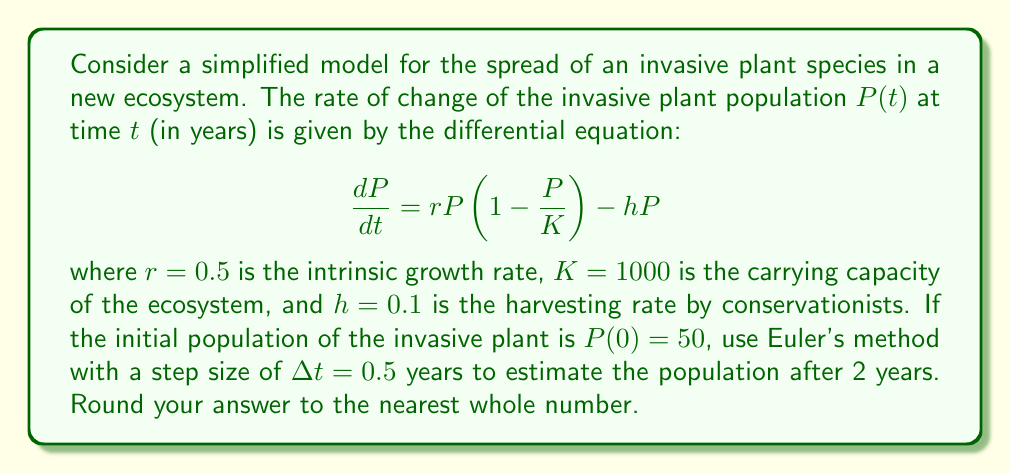Provide a solution to this math problem. To solve this problem using Euler's method, we'll follow these steps:

1) Euler's method is given by the formula:
   $$P_{n+1} = P_n + \Delta t \cdot f(t_n, P_n)$$
   where $f(t, P) = \frac{dP}{dt} = rP(1 - \frac{P}{K}) - hP$

2) Given:
   $r = 0.5$, $K = 1000$, $h = 0.1$, $P(0) = 50$, $\Delta t = 0.5$

3) We need to calculate 4 steps to reach 2 years:
   $t_0 = 0$, $t_1 = 0.5$, $t_2 = 1$, $t_3 = 1.5$, $t_4 = 2$

4) Let's calculate each step:

   Step 1 ($t_0 = 0$ to $t_1 = 0.5$):
   $$f(t_0, P_0) = 0.5 \cdot 50(1 - \frac{50}{1000}) - 0.1 \cdot 50 = 17.75$$
   $$P_1 = 50 + 0.5 \cdot 17.75 = 58.875$$

   Step 2 ($t_1 = 0.5$ to $t_2 = 1$):
   $$f(t_1, P_1) = 0.5 \cdot 58.875(1 - \frac{58.875}{1000}) - 0.1 \cdot 58.875 = 20.39$$
   $$P_2 = 58.875 + 0.5 \cdot 20.39 = 69.07$$

   Step 3 ($t_2 = 1$ to $t_3 = 1.5$):
   $$f(t_2, P_2) = 0.5 \cdot 69.07(1 - \frac{69.07}{1000}) - 0.1 \cdot 69.07 = 23.21$$
   $$P_3 = 69.07 + 0.5 \cdot 23.21 = 80.675$$

   Step 4 ($t_3 = 1.5$ to $t_4 = 2$):
   $$f(t_3, P_3) = 0.5 \cdot 80.675(1 - \frac{80.675}{1000}) - 0.1 \cdot 80.675 = 26.17$$
   $$P_4 = 80.675 + 0.5 \cdot 26.17 = 93.76$$

5) Rounding to the nearest whole number, we get 94.
Answer: 94 